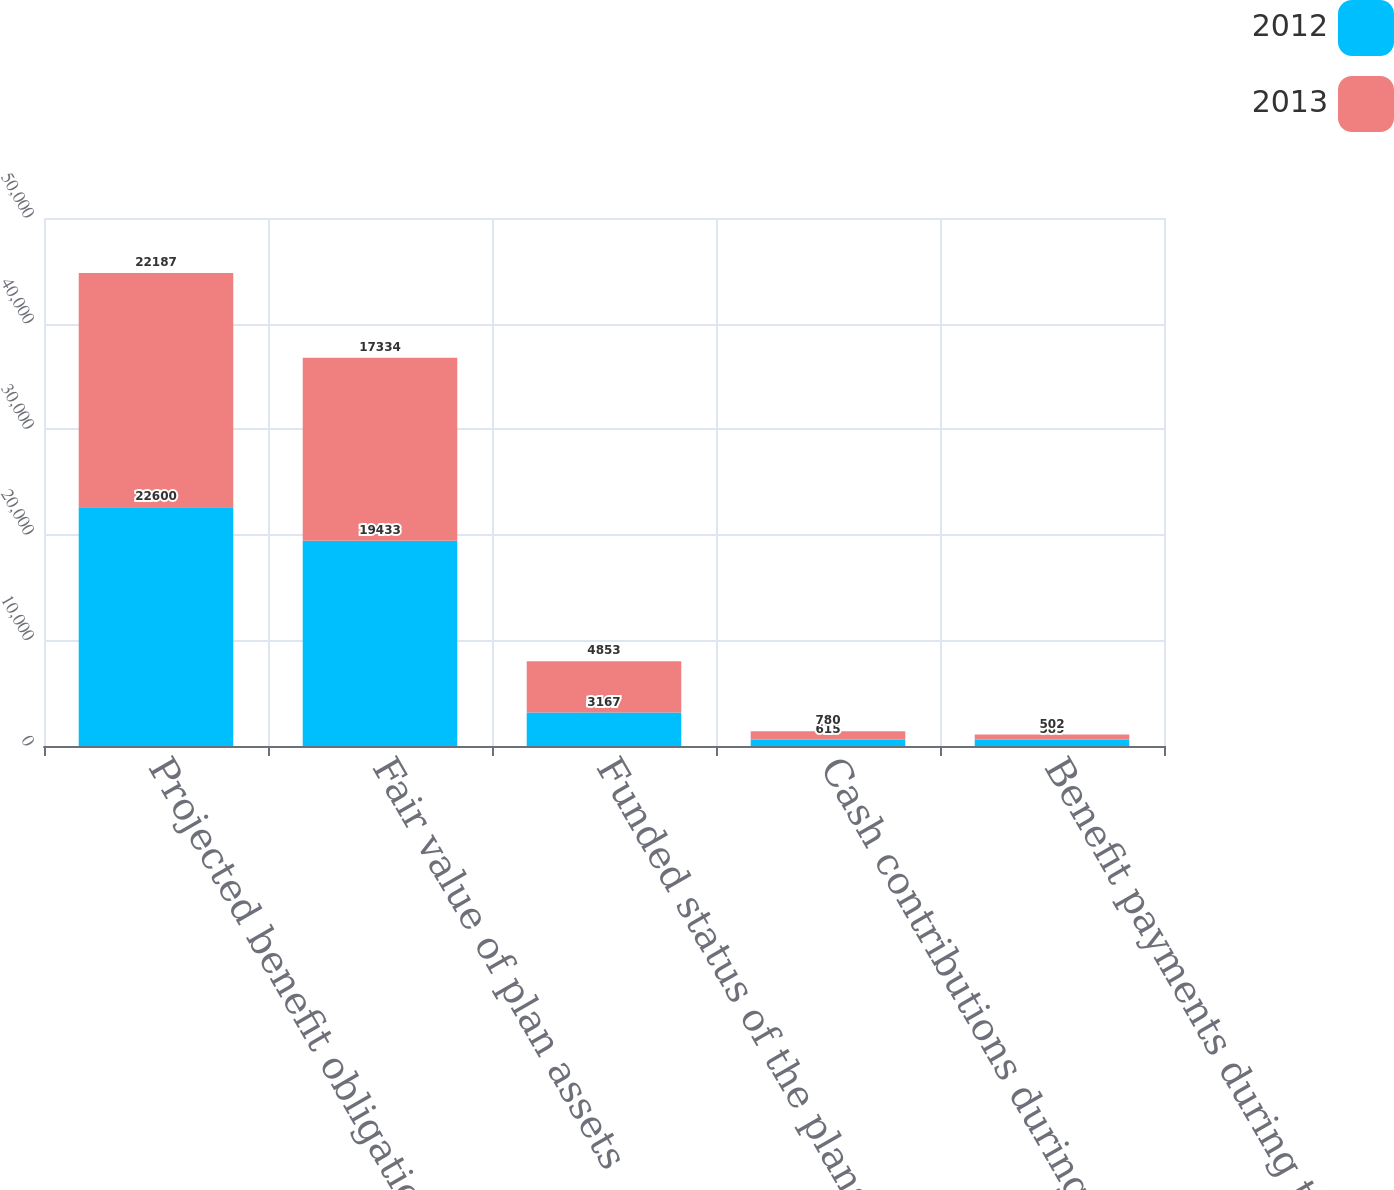<chart> <loc_0><loc_0><loc_500><loc_500><stacked_bar_chart><ecel><fcel>Projected benefit obligation<fcel>Fair value of plan assets<fcel>Funded status of the plans<fcel>Cash contributions during the<fcel>Benefit payments during the<nl><fcel>2012<fcel>22600<fcel>19433<fcel>3167<fcel>615<fcel>589<nl><fcel>2013<fcel>22187<fcel>17334<fcel>4853<fcel>780<fcel>502<nl></chart> 